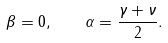Convert formula to latex. <formula><loc_0><loc_0><loc_500><loc_500>\beta = 0 , \quad \alpha = \frac { \gamma + \nu } { 2 } .</formula> 